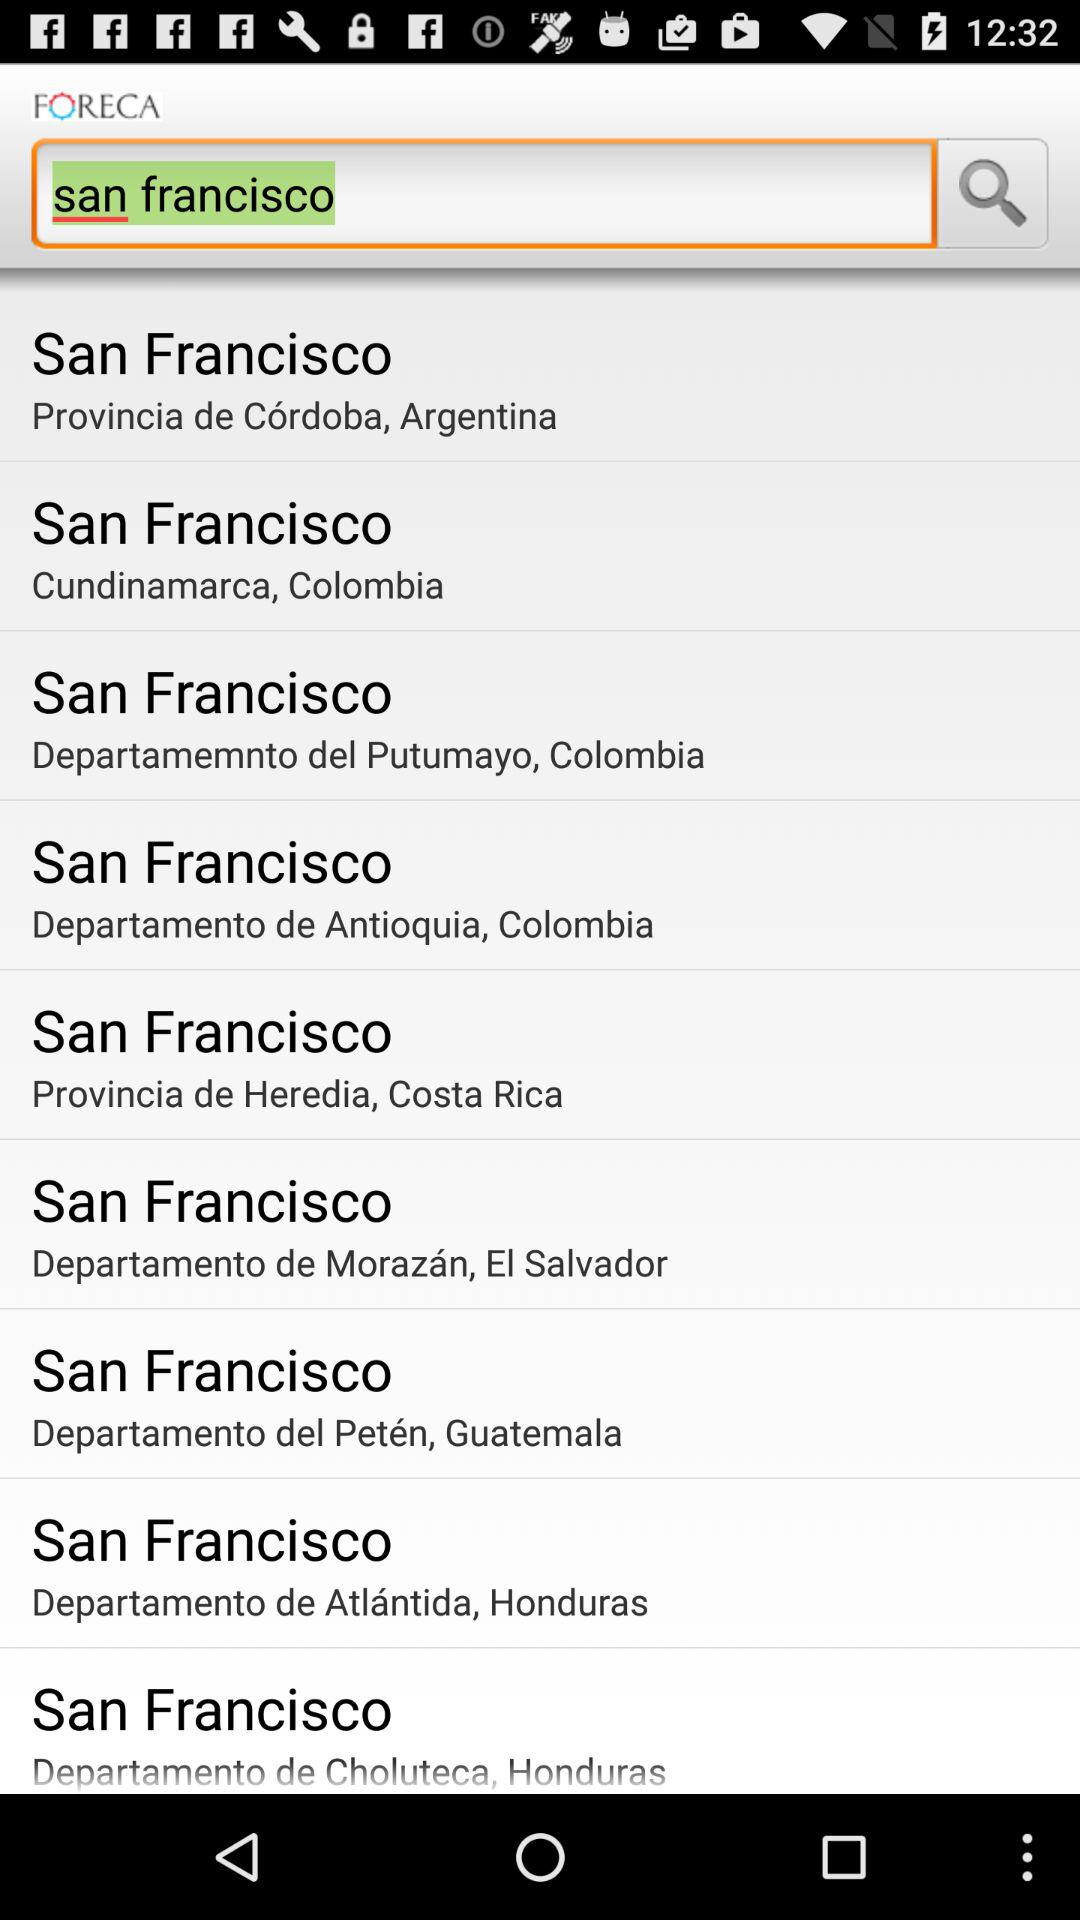What is the application name? The application name is "FORECA". 